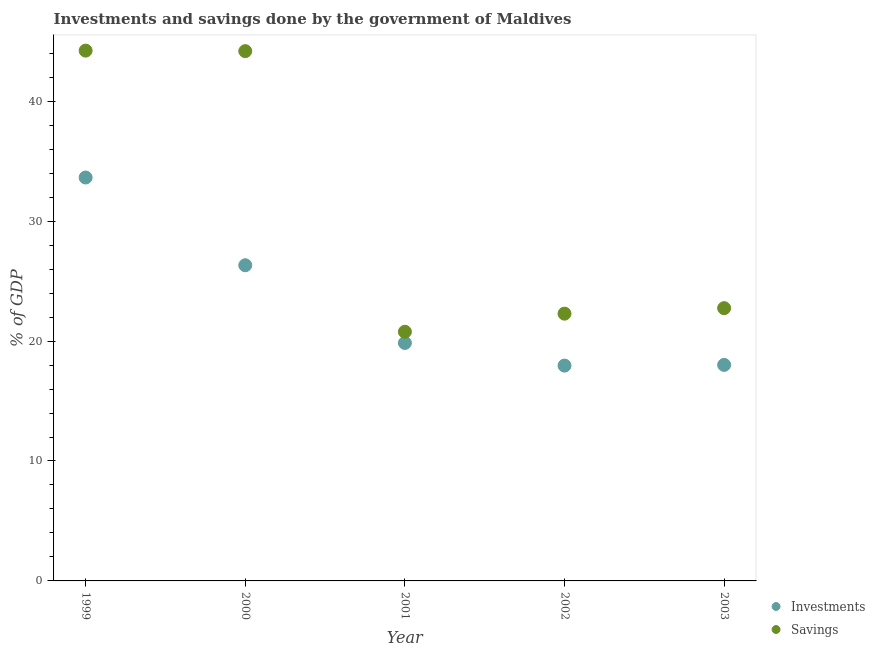How many different coloured dotlines are there?
Your answer should be very brief. 2. What is the investments of government in 2002?
Give a very brief answer. 17.95. Across all years, what is the maximum savings of government?
Your answer should be very brief. 44.22. Across all years, what is the minimum investments of government?
Your answer should be compact. 17.95. In which year was the investments of government maximum?
Your answer should be very brief. 1999. What is the total investments of government in the graph?
Your answer should be very brief. 115.77. What is the difference between the investments of government in 2001 and that in 2002?
Your answer should be very brief. 1.89. What is the difference between the investments of government in 2003 and the savings of government in 1999?
Your answer should be very brief. -26.21. What is the average investments of government per year?
Your answer should be compact. 23.15. In the year 2003, what is the difference between the savings of government and investments of government?
Keep it short and to the point. 4.73. In how many years, is the savings of government greater than 18 %?
Keep it short and to the point. 5. What is the ratio of the savings of government in 2002 to that in 2003?
Provide a succinct answer. 0.98. Is the savings of government in 2001 less than that in 2002?
Provide a succinct answer. Yes. Is the difference between the investments of government in 1999 and 2000 greater than the difference between the savings of government in 1999 and 2000?
Your answer should be very brief. Yes. What is the difference between the highest and the second highest investments of government?
Keep it short and to the point. 7.32. What is the difference between the highest and the lowest investments of government?
Ensure brevity in your answer.  15.68. In how many years, is the investments of government greater than the average investments of government taken over all years?
Your answer should be very brief. 2. Is the sum of the savings of government in 2001 and 2003 greater than the maximum investments of government across all years?
Provide a succinct answer. Yes. Does the investments of government monotonically increase over the years?
Your answer should be compact. No. How many legend labels are there?
Ensure brevity in your answer.  2. How are the legend labels stacked?
Provide a succinct answer. Vertical. What is the title of the graph?
Your answer should be compact. Investments and savings done by the government of Maldives. What is the label or title of the X-axis?
Provide a short and direct response. Year. What is the label or title of the Y-axis?
Your answer should be compact. % of GDP. What is the % of GDP of Investments in 1999?
Ensure brevity in your answer.  33.64. What is the % of GDP in Savings in 1999?
Provide a succinct answer. 44.22. What is the % of GDP in Investments in 2000?
Keep it short and to the point. 26.32. What is the % of GDP of Savings in 2000?
Give a very brief answer. 44.18. What is the % of GDP in Investments in 2001?
Make the answer very short. 19.84. What is the % of GDP of Savings in 2001?
Make the answer very short. 20.78. What is the % of GDP of Investments in 2002?
Provide a succinct answer. 17.95. What is the % of GDP of Savings in 2002?
Make the answer very short. 22.29. What is the % of GDP of Investments in 2003?
Your answer should be compact. 18.01. What is the % of GDP of Savings in 2003?
Provide a short and direct response. 22.75. Across all years, what is the maximum % of GDP of Investments?
Your answer should be compact. 33.64. Across all years, what is the maximum % of GDP in Savings?
Offer a very short reply. 44.22. Across all years, what is the minimum % of GDP of Investments?
Ensure brevity in your answer.  17.95. Across all years, what is the minimum % of GDP of Savings?
Keep it short and to the point. 20.78. What is the total % of GDP in Investments in the graph?
Provide a succinct answer. 115.77. What is the total % of GDP in Savings in the graph?
Provide a succinct answer. 154.21. What is the difference between the % of GDP of Investments in 1999 and that in 2000?
Your answer should be very brief. 7.32. What is the difference between the % of GDP in Savings in 1999 and that in 2000?
Your response must be concise. 0.04. What is the difference between the % of GDP in Investments in 1999 and that in 2001?
Provide a short and direct response. 13.8. What is the difference between the % of GDP of Savings in 1999 and that in 2001?
Offer a very short reply. 23.44. What is the difference between the % of GDP of Investments in 1999 and that in 2002?
Offer a very short reply. 15.68. What is the difference between the % of GDP of Savings in 1999 and that in 2002?
Your answer should be compact. 21.93. What is the difference between the % of GDP of Investments in 1999 and that in 2003?
Your answer should be very brief. 15.63. What is the difference between the % of GDP in Savings in 1999 and that in 2003?
Your answer should be very brief. 21.47. What is the difference between the % of GDP in Investments in 2000 and that in 2001?
Give a very brief answer. 6.48. What is the difference between the % of GDP in Savings in 2000 and that in 2001?
Your response must be concise. 23.4. What is the difference between the % of GDP in Investments in 2000 and that in 2002?
Provide a succinct answer. 8.37. What is the difference between the % of GDP of Savings in 2000 and that in 2002?
Give a very brief answer. 21.89. What is the difference between the % of GDP of Investments in 2000 and that in 2003?
Make the answer very short. 8.31. What is the difference between the % of GDP in Savings in 2000 and that in 2003?
Offer a terse response. 21.43. What is the difference between the % of GDP of Investments in 2001 and that in 2002?
Your response must be concise. 1.89. What is the difference between the % of GDP of Savings in 2001 and that in 2002?
Provide a short and direct response. -1.51. What is the difference between the % of GDP in Investments in 2001 and that in 2003?
Make the answer very short. 1.83. What is the difference between the % of GDP of Savings in 2001 and that in 2003?
Make the answer very short. -1.97. What is the difference between the % of GDP of Investments in 2002 and that in 2003?
Offer a terse response. -0.06. What is the difference between the % of GDP of Savings in 2002 and that in 2003?
Give a very brief answer. -0.46. What is the difference between the % of GDP of Investments in 1999 and the % of GDP of Savings in 2000?
Your response must be concise. -10.54. What is the difference between the % of GDP in Investments in 1999 and the % of GDP in Savings in 2001?
Provide a short and direct response. 12.86. What is the difference between the % of GDP in Investments in 1999 and the % of GDP in Savings in 2002?
Offer a terse response. 11.35. What is the difference between the % of GDP of Investments in 1999 and the % of GDP of Savings in 2003?
Keep it short and to the point. 10.89. What is the difference between the % of GDP of Investments in 2000 and the % of GDP of Savings in 2001?
Your response must be concise. 5.55. What is the difference between the % of GDP in Investments in 2000 and the % of GDP in Savings in 2002?
Give a very brief answer. 4.04. What is the difference between the % of GDP in Investments in 2000 and the % of GDP in Savings in 2003?
Make the answer very short. 3.58. What is the difference between the % of GDP in Investments in 2001 and the % of GDP in Savings in 2002?
Keep it short and to the point. -2.44. What is the difference between the % of GDP in Investments in 2001 and the % of GDP in Savings in 2003?
Your response must be concise. -2.9. What is the difference between the % of GDP in Investments in 2002 and the % of GDP in Savings in 2003?
Offer a very short reply. -4.79. What is the average % of GDP of Investments per year?
Offer a terse response. 23.15. What is the average % of GDP in Savings per year?
Keep it short and to the point. 30.84. In the year 1999, what is the difference between the % of GDP of Investments and % of GDP of Savings?
Make the answer very short. -10.58. In the year 2000, what is the difference between the % of GDP of Investments and % of GDP of Savings?
Make the answer very short. -17.85. In the year 2001, what is the difference between the % of GDP of Investments and % of GDP of Savings?
Your response must be concise. -0.93. In the year 2002, what is the difference between the % of GDP in Investments and % of GDP in Savings?
Your answer should be compact. -4.33. In the year 2003, what is the difference between the % of GDP of Investments and % of GDP of Savings?
Make the answer very short. -4.73. What is the ratio of the % of GDP in Investments in 1999 to that in 2000?
Offer a terse response. 1.28. What is the ratio of the % of GDP in Investments in 1999 to that in 2001?
Your answer should be very brief. 1.7. What is the ratio of the % of GDP of Savings in 1999 to that in 2001?
Your answer should be very brief. 2.13. What is the ratio of the % of GDP of Investments in 1999 to that in 2002?
Provide a short and direct response. 1.87. What is the ratio of the % of GDP of Savings in 1999 to that in 2002?
Give a very brief answer. 1.98. What is the ratio of the % of GDP of Investments in 1999 to that in 2003?
Ensure brevity in your answer.  1.87. What is the ratio of the % of GDP in Savings in 1999 to that in 2003?
Make the answer very short. 1.94. What is the ratio of the % of GDP in Investments in 2000 to that in 2001?
Offer a terse response. 1.33. What is the ratio of the % of GDP in Savings in 2000 to that in 2001?
Your response must be concise. 2.13. What is the ratio of the % of GDP in Investments in 2000 to that in 2002?
Your answer should be compact. 1.47. What is the ratio of the % of GDP of Savings in 2000 to that in 2002?
Ensure brevity in your answer.  1.98. What is the ratio of the % of GDP of Investments in 2000 to that in 2003?
Provide a succinct answer. 1.46. What is the ratio of the % of GDP of Savings in 2000 to that in 2003?
Ensure brevity in your answer.  1.94. What is the ratio of the % of GDP of Investments in 2001 to that in 2002?
Provide a short and direct response. 1.11. What is the ratio of the % of GDP of Savings in 2001 to that in 2002?
Provide a short and direct response. 0.93. What is the ratio of the % of GDP of Investments in 2001 to that in 2003?
Provide a succinct answer. 1.1. What is the ratio of the % of GDP in Savings in 2001 to that in 2003?
Offer a terse response. 0.91. What is the ratio of the % of GDP of Savings in 2002 to that in 2003?
Keep it short and to the point. 0.98. What is the difference between the highest and the second highest % of GDP of Investments?
Give a very brief answer. 7.32. What is the difference between the highest and the second highest % of GDP in Savings?
Provide a short and direct response. 0.04. What is the difference between the highest and the lowest % of GDP of Investments?
Keep it short and to the point. 15.68. What is the difference between the highest and the lowest % of GDP of Savings?
Provide a succinct answer. 23.44. 